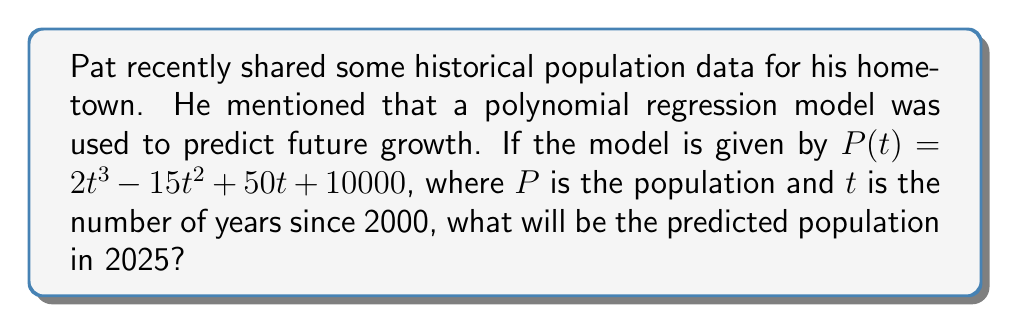Can you answer this question? To solve this problem, we need to follow these steps:

1. Identify the year we're predicting for: 2025
2. Calculate how many years have passed since 2000 (our base year)
3. Plug this value into the polynomial regression model

Step 1: The target year is 2025

Step 2: Years since 2000
$$2025 - 2000 = 25 \text{ years}$$

Step 3: Plug $t = 25$ into the model
$$\begin{align}
P(t) &= 2t^3 - 15t^2 + 50t + 10000 \\
P(25) &= 2(25)^3 - 15(25)^2 + 50(25) + 10000 \\
&= 2(15625) - 15(625) + 50(25) + 10000 \\
&= 31250 - 9375 + 1250 + 10000 \\
&= 33125
\end{align}$$

Therefore, the predicted population for 2025 is 33,125 people.
Answer: 33,125 people 